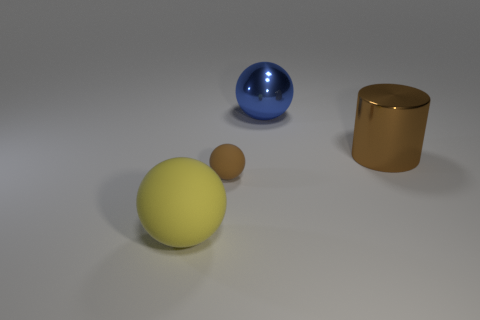Subtract all big metal balls. How many balls are left? 2 Subtract all cylinders. How many objects are left? 3 Add 2 blue shiny spheres. How many blue shiny spheres exist? 3 Add 4 large yellow spheres. How many objects exist? 8 Subtract all blue balls. How many balls are left? 2 Subtract 0 purple blocks. How many objects are left? 4 Subtract 1 cylinders. How many cylinders are left? 0 Subtract all gray balls. Subtract all red cylinders. How many balls are left? 3 Subtract all big gray shiny spheres. Subtract all brown objects. How many objects are left? 2 Add 1 yellow objects. How many yellow objects are left? 2 